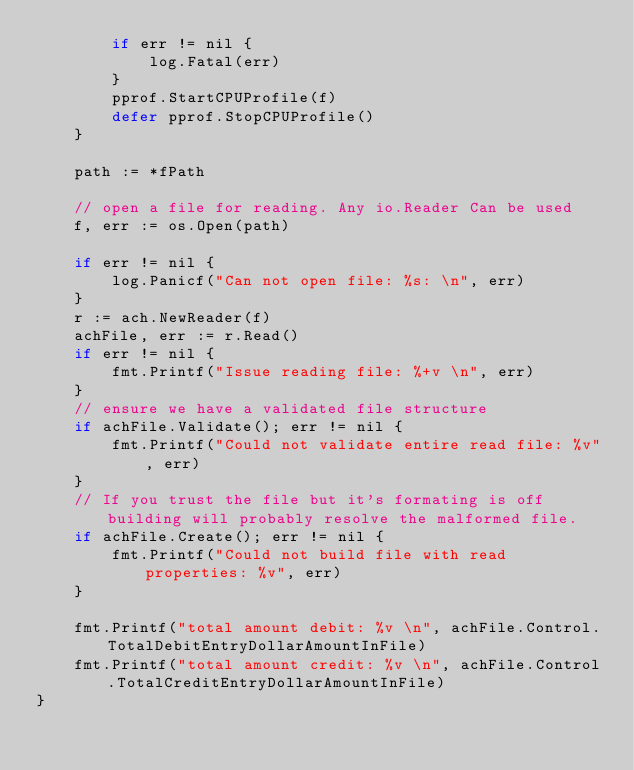Convert code to text. <code><loc_0><loc_0><loc_500><loc_500><_Go_>		if err != nil {
			log.Fatal(err)
		}
		pprof.StartCPUProfile(f)
		defer pprof.StopCPUProfile()
	}

	path := *fPath

	// open a file for reading. Any io.Reader Can be used
	f, err := os.Open(path)

	if err != nil {
		log.Panicf("Can not open file: %s: \n", err)
	}
	r := ach.NewReader(f)
	achFile, err := r.Read()
	if err != nil {
		fmt.Printf("Issue reading file: %+v \n", err)
	}
	// ensure we have a validated file structure
	if achFile.Validate(); err != nil {
		fmt.Printf("Could not validate entire read file: %v", err)
	}
	// If you trust the file but it's formating is off building will probably resolve the malformed file.
	if achFile.Create(); err != nil {
		fmt.Printf("Could not build file with read properties: %v", err)
	}

	fmt.Printf("total amount debit: %v \n", achFile.Control.TotalDebitEntryDollarAmountInFile)
	fmt.Printf("total amount credit: %v \n", achFile.Control.TotalCreditEntryDollarAmountInFile)
}
</code> 